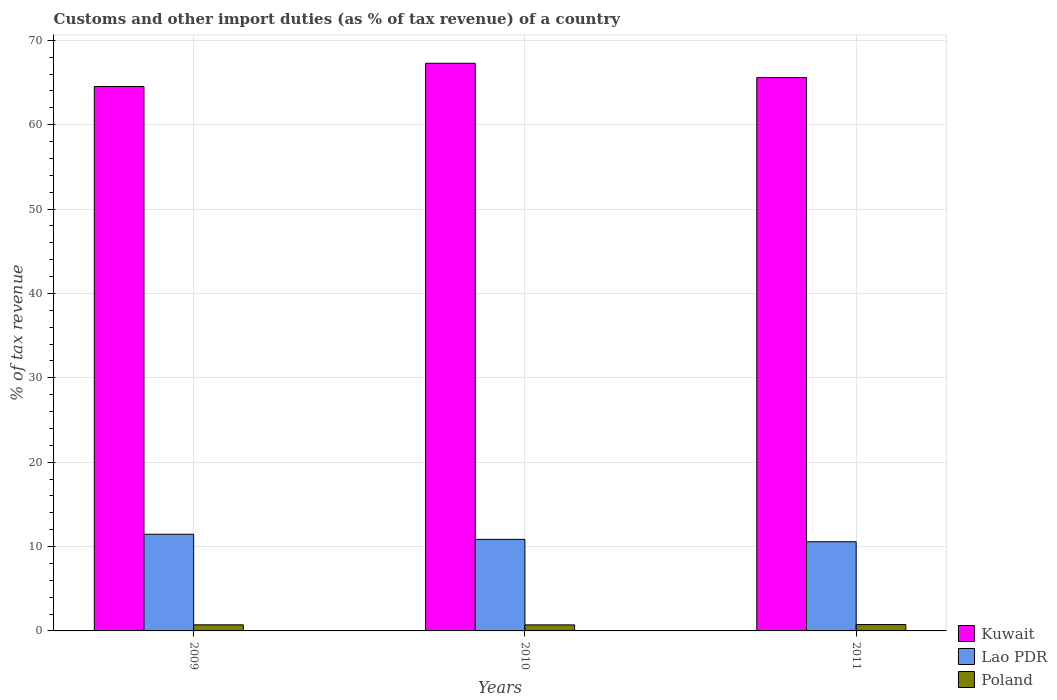How many different coloured bars are there?
Your answer should be very brief. 3. Are the number of bars per tick equal to the number of legend labels?
Offer a terse response. Yes. Are the number of bars on each tick of the X-axis equal?
Offer a very short reply. Yes. What is the label of the 1st group of bars from the left?
Your answer should be very brief. 2009. In how many cases, is the number of bars for a given year not equal to the number of legend labels?
Offer a terse response. 0. What is the percentage of tax revenue from customs in Lao PDR in 2010?
Keep it short and to the point. 10.85. Across all years, what is the maximum percentage of tax revenue from customs in Poland?
Provide a succinct answer. 0.75. Across all years, what is the minimum percentage of tax revenue from customs in Lao PDR?
Your answer should be compact. 10.57. In which year was the percentage of tax revenue from customs in Lao PDR maximum?
Provide a short and direct response. 2009. What is the total percentage of tax revenue from customs in Lao PDR in the graph?
Offer a very short reply. 32.88. What is the difference between the percentage of tax revenue from customs in Kuwait in 2010 and that in 2011?
Provide a succinct answer. 1.7. What is the difference between the percentage of tax revenue from customs in Poland in 2011 and the percentage of tax revenue from customs in Lao PDR in 2010?
Your answer should be compact. -10.1. What is the average percentage of tax revenue from customs in Kuwait per year?
Provide a succinct answer. 65.8. In the year 2011, what is the difference between the percentage of tax revenue from customs in Lao PDR and percentage of tax revenue from customs in Kuwait?
Make the answer very short. -55.02. In how many years, is the percentage of tax revenue from customs in Kuwait greater than 6 %?
Your answer should be very brief. 3. What is the ratio of the percentage of tax revenue from customs in Poland in 2009 to that in 2010?
Give a very brief answer. 1.01. Is the percentage of tax revenue from customs in Kuwait in 2009 less than that in 2011?
Your answer should be compact. Yes. Is the difference between the percentage of tax revenue from customs in Lao PDR in 2009 and 2010 greater than the difference between the percentage of tax revenue from customs in Kuwait in 2009 and 2010?
Your answer should be compact. Yes. What is the difference between the highest and the second highest percentage of tax revenue from customs in Lao PDR?
Keep it short and to the point. 0.61. What is the difference between the highest and the lowest percentage of tax revenue from customs in Kuwait?
Provide a succinct answer. 2.76. In how many years, is the percentage of tax revenue from customs in Poland greater than the average percentage of tax revenue from customs in Poland taken over all years?
Offer a terse response. 1. Is the sum of the percentage of tax revenue from customs in Poland in 2010 and 2011 greater than the maximum percentage of tax revenue from customs in Kuwait across all years?
Your response must be concise. No. What does the 2nd bar from the left in 2010 represents?
Your response must be concise. Lao PDR. What does the 2nd bar from the right in 2010 represents?
Your answer should be very brief. Lao PDR. How many bars are there?
Your answer should be very brief. 9. What is the difference between two consecutive major ticks on the Y-axis?
Provide a succinct answer. 10. Does the graph contain grids?
Your answer should be very brief. Yes. Where does the legend appear in the graph?
Ensure brevity in your answer.  Bottom right. How are the legend labels stacked?
Offer a very short reply. Vertical. What is the title of the graph?
Provide a succinct answer. Customs and other import duties (as % of tax revenue) of a country. Does "Romania" appear as one of the legend labels in the graph?
Keep it short and to the point. No. What is the label or title of the X-axis?
Ensure brevity in your answer.  Years. What is the label or title of the Y-axis?
Your answer should be compact. % of tax revenue. What is the % of tax revenue in Kuwait in 2009?
Offer a terse response. 64.53. What is the % of tax revenue of Lao PDR in 2009?
Make the answer very short. 11.46. What is the % of tax revenue of Poland in 2009?
Give a very brief answer. 0.72. What is the % of tax revenue of Kuwait in 2010?
Offer a very short reply. 67.28. What is the % of tax revenue of Lao PDR in 2010?
Your answer should be compact. 10.85. What is the % of tax revenue of Poland in 2010?
Offer a very short reply. 0.72. What is the % of tax revenue in Kuwait in 2011?
Your response must be concise. 65.59. What is the % of tax revenue in Lao PDR in 2011?
Ensure brevity in your answer.  10.57. What is the % of tax revenue in Poland in 2011?
Give a very brief answer. 0.75. Across all years, what is the maximum % of tax revenue in Kuwait?
Offer a very short reply. 67.28. Across all years, what is the maximum % of tax revenue of Lao PDR?
Provide a short and direct response. 11.46. Across all years, what is the maximum % of tax revenue in Poland?
Make the answer very short. 0.75. Across all years, what is the minimum % of tax revenue in Kuwait?
Offer a terse response. 64.53. Across all years, what is the minimum % of tax revenue in Lao PDR?
Your answer should be very brief. 10.57. Across all years, what is the minimum % of tax revenue of Poland?
Give a very brief answer. 0.72. What is the total % of tax revenue in Kuwait in the graph?
Ensure brevity in your answer.  197.4. What is the total % of tax revenue in Lao PDR in the graph?
Offer a terse response. 32.88. What is the total % of tax revenue in Poland in the graph?
Your response must be concise. 2.19. What is the difference between the % of tax revenue in Kuwait in 2009 and that in 2010?
Your response must be concise. -2.76. What is the difference between the % of tax revenue of Lao PDR in 2009 and that in 2010?
Make the answer very short. 0.61. What is the difference between the % of tax revenue of Poland in 2009 and that in 2010?
Provide a short and direct response. 0.01. What is the difference between the % of tax revenue in Kuwait in 2009 and that in 2011?
Your answer should be compact. -1.06. What is the difference between the % of tax revenue in Lao PDR in 2009 and that in 2011?
Give a very brief answer. 0.89. What is the difference between the % of tax revenue in Poland in 2009 and that in 2011?
Your answer should be very brief. -0.03. What is the difference between the % of tax revenue in Kuwait in 2010 and that in 2011?
Your response must be concise. 1.7. What is the difference between the % of tax revenue of Lao PDR in 2010 and that in 2011?
Keep it short and to the point. 0.28. What is the difference between the % of tax revenue in Poland in 2010 and that in 2011?
Make the answer very short. -0.04. What is the difference between the % of tax revenue in Kuwait in 2009 and the % of tax revenue in Lao PDR in 2010?
Your answer should be compact. 53.68. What is the difference between the % of tax revenue of Kuwait in 2009 and the % of tax revenue of Poland in 2010?
Offer a terse response. 63.81. What is the difference between the % of tax revenue in Lao PDR in 2009 and the % of tax revenue in Poland in 2010?
Ensure brevity in your answer.  10.74. What is the difference between the % of tax revenue in Kuwait in 2009 and the % of tax revenue in Lao PDR in 2011?
Your answer should be very brief. 53.96. What is the difference between the % of tax revenue of Kuwait in 2009 and the % of tax revenue of Poland in 2011?
Give a very brief answer. 63.77. What is the difference between the % of tax revenue in Lao PDR in 2009 and the % of tax revenue in Poland in 2011?
Your response must be concise. 10.71. What is the difference between the % of tax revenue in Kuwait in 2010 and the % of tax revenue in Lao PDR in 2011?
Provide a succinct answer. 56.72. What is the difference between the % of tax revenue of Kuwait in 2010 and the % of tax revenue of Poland in 2011?
Provide a short and direct response. 66.53. What is the difference between the % of tax revenue in Lao PDR in 2010 and the % of tax revenue in Poland in 2011?
Your answer should be very brief. 10.1. What is the average % of tax revenue of Kuwait per year?
Provide a short and direct response. 65.8. What is the average % of tax revenue in Lao PDR per year?
Offer a very short reply. 10.96. What is the average % of tax revenue of Poland per year?
Make the answer very short. 0.73. In the year 2009, what is the difference between the % of tax revenue in Kuwait and % of tax revenue in Lao PDR?
Your answer should be very brief. 53.07. In the year 2009, what is the difference between the % of tax revenue of Kuwait and % of tax revenue of Poland?
Your answer should be compact. 63.8. In the year 2009, what is the difference between the % of tax revenue in Lao PDR and % of tax revenue in Poland?
Make the answer very short. 10.74. In the year 2010, what is the difference between the % of tax revenue in Kuwait and % of tax revenue in Lao PDR?
Offer a very short reply. 56.43. In the year 2010, what is the difference between the % of tax revenue in Kuwait and % of tax revenue in Poland?
Provide a succinct answer. 66.57. In the year 2010, what is the difference between the % of tax revenue of Lao PDR and % of tax revenue of Poland?
Offer a terse response. 10.13. In the year 2011, what is the difference between the % of tax revenue of Kuwait and % of tax revenue of Lao PDR?
Give a very brief answer. 55.02. In the year 2011, what is the difference between the % of tax revenue of Kuwait and % of tax revenue of Poland?
Offer a terse response. 64.83. In the year 2011, what is the difference between the % of tax revenue of Lao PDR and % of tax revenue of Poland?
Provide a short and direct response. 9.81. What is the ratio of the % of tax revenue of Lao PDR in 2009 to that in 2010?
Your response must be concise. 1.06. What is the ratio of the % of tax revenue in Poland in 2009 to that in 2010?
Your response must be concise. 1.01. What is the ratio of the % of tax revenue of Kuwait in 2009 to that in 2011?
Make the answer very short. 0.98. What is the ratio of the % of tax revenue of Lao PDR in 2009 to that in 2011?
Your response must be concise. 1.08. What is the ratio of the % of tax revenue in Poland in 2009 to that in 2011?
Make the answer very short. 0.96. What is the ratio of the % of tax revenue in Kuwait in 2010 to that in 2011?
Keep it short and to the point. 1.03. What is the ratio of the % of tax revenue of Lao PDR in 2010 to that in 2011?
Your response must be concise. 1.03. What is the ratio of the % of tax revenue of Poland in 2010 to that in 2011?
Offer a very short reply. 0.95. What is the difference between the highest and the second highest % of tax revenue of Kuwait?
Your answer should be compact. 1.7. What is the difference between the highest and the second highest % of tax revenue in Lao PDR?
Provide a short and direct response. 0.61. What is the difference between the highest and the second highest % of tax revenue of Poland?
Ensure brevity in your answer.  0.03. What is the difference between the highest and the lowest % of tax revenue of Kuwait?
Make the answer very short. 2.76. What is the difference between the highest and the lowest % of tax revenue of Lao PDR?
Your answer should be very brief. 0.89. What is the difference between the highest and the lowest % of tax revenue of Poland?
Your answer should be compact. 0.04. 